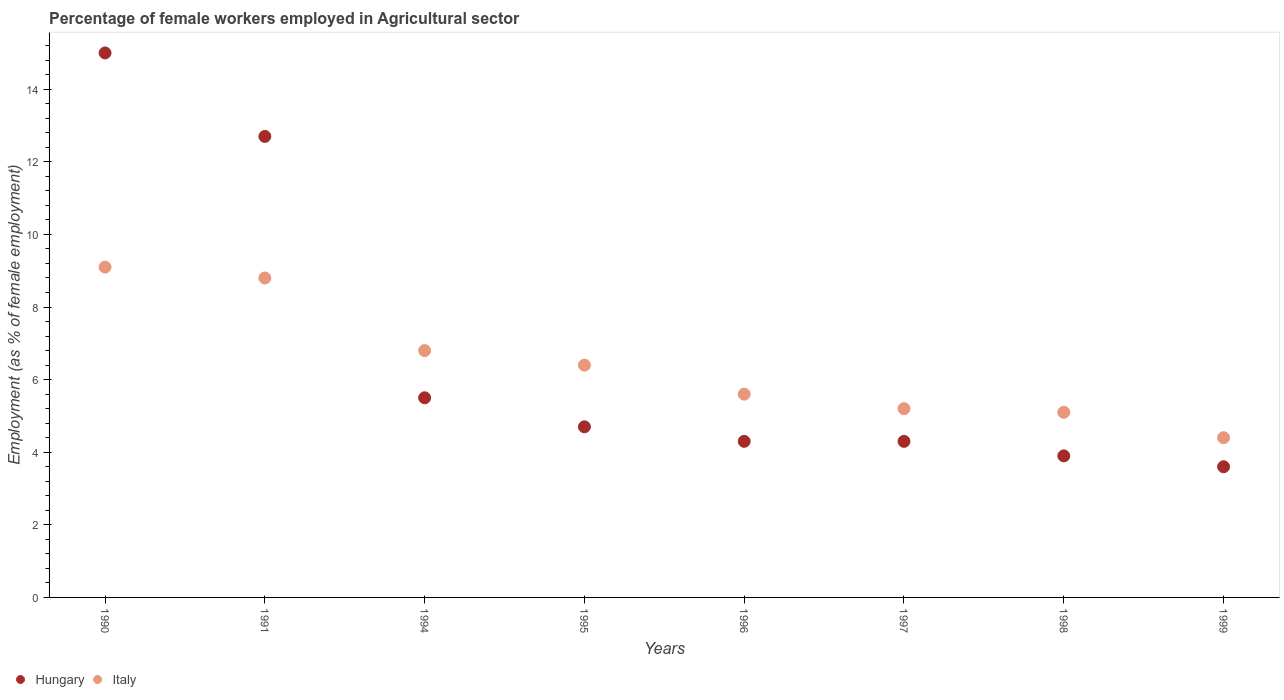How many different coloured dotlines are there?
Your answer should be compact. 2. What is the percentage of females employed in Agricultural sector in Italy in 1995?
Keep it short and to the point. 6.4. Across all years, what is the maximum percentage of females employed in Agricultural sector in Hungary?
Your answer should be compact. 15. Across all years, what is the minimum percentage of females employed in Agricultural sector in Hungary?
Provide a succinct answer. 3.6. In which year was the percentage of females employed in Agricultural sector in Italy minimum?
Provide a succinct answer. 1999. What is the total percentage of females employed in Agricultural sector in Hungary in the graph?
Offer a very short reply. 54. What is the difference between the percentage of females employed in Agricultural sector in Hungary in 1991 and that in 1995?
Offer a terse response. 8. What is the difference between the percentage of females employed in Agricultural sector in Hungary in 1990 and the percentage of females employed in Agricultural sector in Italy in 1996?
Offer a terse response. 9.4. What is the average percentage of females employed in Agricultural sector in Italy per year?
Make the answer very short. 6.43. In the year 1990, what is the difference between the percentage of females employed in Agricultural sector in Italy and percentage of females employed in Agricultural sector in Hungary?
Offer a very short reply. -5.9. What is the ratio of the percentage of females employed in Agricultural sector in Hungary in 1991 to that in 1998?
Provide a succinct answer. 3.26. Is the percentage of females employed in Agricultural sector in Hungary in 1990 less than that in 1997?
Your response must be concise. No. Is the difference between the percentage of females employed in Agricultural sector in Italy in 1991 and 1998 greater than the difference between the percentage of females employed in Agricultural sector in Hungary in 1991 and 1998?
Your response must be concise. No. What is the difference between the highest and the second highest percentage of females employed in Agricultural sector in Italy?
Your response must be concise. 0.3. What is the difference between the highest and the lowest percentage of females employed in Agricultural sector in Hungary?
Your response must be concise. 11.4. Is the percentage of females employed in Agricultural sector in Italy strictly greater than the percentage of females employed in Agricultural sector in Hungary over the years?
Provide a succinct answer. No. Is the percentage of females employed in Agricultural sector in Hungary strictly less than the percentage of females employed in Agricultural sector in Italy over the years?
Offer a terse response. No. How many years are there in the graph?
Provide a short and direct response. 8. What is the difference between two consecutive major ticks on the Y-axis?
Offer a terse response. 2. Are the values on the major ticks of Y-axis written in scientific E-notation?
Your answer should be very brief. No. What is the title of the graph?
Your answer should be compact. Percentage of female workers employed in Agricultural sector. What is the label or title of the Y-axis?
Your answer should be very brief. Employment (as % of female employment). What is the Employment (as % of female employment) in Hungary in 1990?
Provide a succinct answer. 15. What is the Employment (as % of female employment) in Italy in 1990?
Keep it short and to the point. 9.1. What is the Employment (as % of female employment) of Hungary in 1991?
Offer a terse response. 12.7. What is the Employment (as % of female employment) of Italy in 1991?
Provide a short and direct response. 8.8. What is the Employment (as % of female employment) of Italy in 1994?
Your answer should be compact. 6.8. What is the Employment (as % of female employment) in Hungary in 1995?
Keep it short and to the point. 4.7. What is the Employment (as % of female employment) in Italy in 1995?
Keep it short and to the point. 6.4. What is the Employment (as % of female employment) in Hungary in 1996?
Your response must be concise. 4.3. What is the Employment (as % of female employment) in Italy in 1996?
Your answer should be compact. 5.6. What is the Employment (as % of female employment) of Hungary in 1997?
Provide a short and direct response. 4.3. What is the Employment (as % of female employment) in Italy in 1997?
Make the answer very short. 5.2. What is the Employment (as % of female employment) in Hungary in 1998?
Your response must be concise. 3.9. What is the Employment (as % of female employment) of Italy in 1998?
Provide a short and direct response. 5.1. What is the Employment (as % of female employment) of Hungary in 1999?
Provide a succinct answer. 3.6. What is the Employment (as % of female employment) in Italy in 1999?
Provide a short and direct response. 4.4. Across all years, what is the maximum Employment (as % of female employment) in Hungary?
Your response must be concise. 15. Across all years, what is the maximum Employment (as % of female employment) in Italy?
Offer a very short reply. 9.1. Across all years, what is the minimum Employment (as % of female employment) in Hungary?
Your answer should be very brief. 3.6. Across all years, what is the minimum Employment (as % of female employment) in Italy?
Give a very brief answer. 4.4. What is the total Employment (as % of female employment) of Italy in the graph?
Provide a short and direct response. 51.4. What is the difference between the Employment (as % of female employment) of Italy in 1990 and that in 1991?
Make the answer very short. 0.3. What is the difference between the Employment (as % of female employment) in Hungary in 1990 and that in 1994?
Give a very brief answer. 9.5. What is the difference between the Employment (as % of female employment) in Hungary in 1990 and that in 1995?
Keep it short and to the point. 10.3. What is the difference between the Employment (as % of female employment) in Italy in 1990 and that in 1996?
Provide a short and direct response. 3.5. What is the difference between the Employment (as % of female employment) of Italy in 1990 and that in 1998?
Your answer should be very brief. 4. What is the difference between the Employment (as % of female employment) in Italy in 1990 and that in 1999?
Make the answer very short. 4.7. What is the difference between the Employment (as % of female employment) in Hungary in 1991 and that in 1994?
Your response must be concise. 7.2. What is the difference between the Employment (as % of female employment) of Italy in 1991 and that in 1994?
Provide a succinct answer. 2. What is the difference between the Employment (as % of female employment) in Hungary in 1991 and that in 1997?
Offer a very short reply. 8.4. What is the difference between the Employment (as % of female employment) of Italy in 1991 and that in 1999?
Your answer should be compact. 4.4. What is the difference between the Employment (as % of female employment) of Hungary in 1994 and that in 1995?
Provide a succinct answer. 0.8. What is the difference between the Employment (as % of female employment) of Italy in 1994 and that in 1995?
Make the answer very short. 0.4. What is the difference between the Employment (as % of female employment) of Italy in 1994 and that in 1996?
Your answer should be compact. 1.2. What is the difference between the Employment (as % of female employment) in Italy in 1994 and that in 1997?
Give a very brief answer. 1.6. What is the difference between the Employment (as % of female employment) of Italy in 1994 and that in 1999?
Ensure brevity in your answer.  2.4. What is the difference between the Employment (as % of female employment) of Hungary in 1995 and that in 1996?
Offer a very short reply. 0.4. What is the difference between the Employment (as % of female employment) of Hungary in 1995 and that in 1997?
Keep it short and to the point. 0.4. What is the difference between the Employment (as % of female employment) of Italy in 1995 and that in 1997?
Provide a short and direct response. 1.2. What is the difference between the Employment (as % of female employment) in Italy in 1995 and that in 1999?
Provide a succinct answer. 2. What is the difference between the Employment (as % of female employment) in Hungary in 1996 and that in 1998?
Offer a very short reply. 0.4. What is the difference between the Employment (as % of female employment) in Italy in 1996 and that in 1999?
Provide a short and direct response. 1.2. What is the difference between the Employment (as % of female employment) in Hungary in 1997 and that in 1999?
Your response must be concise. 0.7. What is the difference between the Employment (as % of female employment) in Hungary in 1990 and the Employment (as % of female employment) in Italy in 1991?
Offer a terse response. 6.2. What is the difference between the Employment (as % of female employment) of Hungary in 1990 and the Employment (as % of female employment) of Italy in 1994?
Your response must be concise. 8.2. What is the difference between the Employment (as % of female employment) in Hungary in 1990 and the Employment (as % of female employment) in Italy in 1996?
Give a very brief answer. 9.4. What is the difference between the Employment (as % of female employment) of Hungary in 1991 and the Employment (as % of female employment) of Italy in 1994?
Make the answer very short. 5.9. What is the difference between the Employment (as % of female employment) in Hungary in 1994 and the Employment (as % of female employment) in Italy in 1998?
Provide a short and direct response. 0.4. What is the difference between the Employment (as % of female employment) in Hungary in 1995 and the Employment (as % of female employment) in Italy in 1996?
Provide a short and direct response. -0.9. What is the difference between the Employment (as % of female employment) in Hungary in 1996 and the Employment (as % of female employment) in Italy in 1998?
Your answer should be compact. -0.8. What is the difference between the Employment (as % of female employment) of Hungary in 1996 and the Employment (as % of female employment) of Italy in 1999?
Your answer should be compact. -0.1. What is the difference between the Employment (as % of female employment) in Hungary in 1997 and the Employment (as % of female employment) in Italy in 1998?
Make the answer very short. -0.8. What is the difference between the Employment (as % of female employment) in Hungary in 1998 and the Employment (as % of female employment) in Italy in 1999?
Your answer should be compact. -0.5. What is the average Employment (as % of female employment) of Hungary per year?
Offer a terse response. 6.75. What is the average Employment (as % of female employment) in Italy per year?
Your answer should be compact. 6.42. In the year 1990, what is the difference between the Employment (as % of female employment) in Hungary and Employment (as % of female employment) in Italy?
Give a very brief answer. 5.9. In the year 1991, what is the difference between the Employment (as % of female employment) in Hungary and Employment (as % of female employment) in Italy?
Make the answer very short. 3.9. In the year 1994, what is the difference between the Employment (as % of female employment) in Hungary and Employment (as % of female employment) in Italy?
Make the answer very short. -1.3. In the year 1995, what is the difference between the Employment (as % of female employment) of Hungary and Employment (as % of female employment) of Italy?
Your answer should be very brief. -1.7. In the year 1997, what is the difference between the Employment (as % of female employment) in Hungary and Employment (as % of female employment) in Italy?
Provide a succinct answer. -0.9. In the year 1999, what is the difference between the Employment (as % of female employment) of Hungary and Employment (as % of female employment) of Italy?
Offer a terse response. -0.8. What is the ratio of the Employment (as % of female employment) in Hungary in 1990 to that in 1991?
Provide a succinct answer. 1.18. What is the ratio of the Employment (as % of female employment) in Italy in 1990 to that in 1991?
Your response must be concise. 1.03. What is the ratio of the Employment (as % of female employment) in Hungary in 1990 to that in 1994?
Make the answer very short. 2.73. What is the ratio of the Employment (as % of female employment) in Italy in 1990 to that in 1994?
Your answer should be very brief. 1.34. What is the ratio of the Employment (as % of female employment) of Hungary in 1990 to that in 1995?
Provide a short and direct response. 3.19. What is the ratio of the Employment (as % of female employment) of Italy in 1990 to that in 1995?
Ensure brevity in your answer.  1.42. What is the ratio of the Employment (as % of female employment) of Hungary in 1990 to that in 1996?
Provide a succinct answer. 3.49. What is the ratio of the Employment (as % of female employment) in Italy in 1990 to that in 1996?
Your answer should be compact. 1.62. What is the ratio of the Employment (as % of female employment) of Hungary in 1990 to that in 1997?
Provide a succinct answer. 3.49. What is the ratio of the Employment (as % of female employment) of Italy in 1990 to that in 1997?
Keep it short and to the point. 1.75. What is the ratio of the Employment (as % of female employment) in Hungary in 1990 to that in 1998?
Your answer should be very brief. 3.85. What is the ratio of the Employment (as % of female employment) in Italy in 1990 to that in 1998?
Offer a terse response. 1.78. What is the ratio of the Employment (as % of female employment) of Hungary in 1990 to that in 1999?
Offer a very short reply. 4.17. What is the ratio of the Employment (as % of female employment) in Italy in 1990 to that in 1999?
Keep it short and to the point. 2.07. What is the ratio of the Employment (as % of female employment) of Hungary in 1991 to that in 1994?
Keep it short and to the point. 2.31. What is the ratio of the Employment (as % of female employment) in Italy in 1991 to that in 1994?
Provide a short and direct response. 1.29. What is the ratio of the Employment (as % of female employment) of Hungary in 1991 to that in 1995?
Provide a succinct answer. 2.7. What is the ratio of the Employment (as % of female employment) in Italy in 1991 to that in 1995?
Give a very brief answer. 1.38. What is the ratio of the Employment (as % of female employment) of Hungary in 1991 to that in 1996?
Offer a very short reply. 2.95. What is the ratio of the Employment (as % of female employment) in Italy in 1991 to that in 1996?
Offer a very short reply. 1.57. What is the ratio of the Employment (as % of female employment) in Hungary in 1991 to that in 1997?
Make the answer very short. 2.95. What is the ratio of the Employment (as % of female employment) in Italy in 1991 to that in 1997?
Ensure brevity in your answer.  1.69. What is the ratio of the Employment (as % of female employment) in Hungary in 1991 to that in 1998?
Provide a short and direct response. 3.26. What is the ratio of the Employment (as % of female employment) in Italy in 1991 to that in 1998?
Offer a terse response. 1.73. What is the ratio of the Employment (as % of female employment) of Hungary in 1991 to that in 1999?
Make the answer very short. 3.53. What is the ratio of the Employment (as % of female employment) in Italy in 1991 to that in 1999?
Ensure brevity in your answer.  2. What is the ratio of the Employment (as % of female employment) of Hungary in 1994 to that in 1995?
Your answer should be very brief. 1.17. What is the ratio of the Employment (as % of female employment) of Italy in 1994 to that in 1995?
Offer a terse response. 1.06. What is the ratio of the Employment (as % of female employment) of Hungary in 1994 to that in 1996?
Your response must be concise. 1.28. What is the ratio of the Employment (as % of female employment) of Italy in 1994 to that in 1996?
Give a very brief answer. 1.21. What is the ratio of the Employment (as % of female employment) of Hungary in 1994 to that in 1997?
Make the answer very short. 1.28. What is the ratio of the Employment (as % of female employment) in Italy in 1994 to that in 1997?
Your response must be concise. 1.31. What is the ratio of the Employment (as % of female employment) of Hungary in 1994 to that in 1998?
Your answer should be compact. 1.41. What is the ratio of the Employment (as % of female employment) of Italy in 1994 to that in 1998?
Keep it short and to the point. 1.33. What is the ratio of the Employment (as % of female employment) in Hungary in 1994 to that in 1999?
Your answer should be compact. 1.53. What is the ratio of the Employment (as % of female employment) in Italy in 1994 to that in 1999?
Ensure brevity in your answer.  1.55. What is the ratio of the Employment (as % of female employment) of Hungary in 1995 to that in 1996?
Your response must be concise. 1.09. What is the ratio of the Employment (as % of female employment) in Italy in 1995 to that in 1996?
Your answer should be compact. 1.14. What is the ratio of the Employment (as % of female employment) in Hungary in 1995 to that in 1997?
Keep it short and to the point. 1.09. What is the ratio of the Employment (as % of female employment) of Italy in 1995 to that in 1997?
Your answer should be compact. 1.23. What is the ratio of the Employment (as % of female employment) of Hungary in 1995 to that in 1998?
Give a very brief answer. 1.21. What is the ratio of the Employment (as % of female employment) in Italy in 1995 to that in 1998?
Provide a short and direct response. 1.25. What is the ratio of the Employment (as % of female employment) of Hungary in 1995 to that in 1999?
Your answer should be very brief. 1.31. What is the ratio of the Employment (as % of female employment) in Italy in 1995 to that in 1999?
Your answer should be very brief. 1.45. What is the ratio of the Employment (as % of female employment) of Hungary in 1996 to that in 1997?
Provide a succinct answer. 1. What is the ratio of the Employment (as % of female employment) in Italy in 1996 to that in 1997?
Provide a succinct answer. 1.08. What is the ratio of the Employment (as % of female employment) in Hungary in 1996 to that in 1998?
Keep it short and to the point. 1.1. What is the ratio of the Employment (as % of female employment) in Italy in 1996 to that in 1998?
Offer a terse response. 1.1. What is the ratio of the Employment (as % of female employment) of Hungary in 1996 to that in 1999?
Keep it short and to the point. 1.19. What is the ratio of the Employment (as % of female employment) in Italy in 1996 to that in 1999?
Keep it short and to the point. 1.27. What is the ratio of the Employment (as % of female employment) of Hungary in 1997 to that in 1998?
Your answer should be compact. 1.1. What is the ratio of the Employment (as % of female employment) in Italy in 1997 to that in 1998?
Provide a succinct answer. 1.02. What is the ratio of the Employment (as % of female employment) of Hungary in 1997 to that in 1999?
Offer a terse response. 1.19. What is the ratio of the Employment (as % of female employment) of Italy in 1997 to that in 1999?
Offer a very short reply. 1.18. What is the ratio of the Employment (as % of female employment) in Hungary in 1998 to that in 1999?
Your response must be concise. 1.08. What is the ratio of the Employment (as % of female employment) in Italy in 1998 to that in 1999?
Make the answer very short. 1.16. What is the difference between the highest and the second highest Employment (as % of female employment) in Hungary?
Your answer should be very brief. 2.3. What is the difference between the highest and the second highest Employment (as % of female employment) in Italy?
Your answer should be very brief. 0.3. 